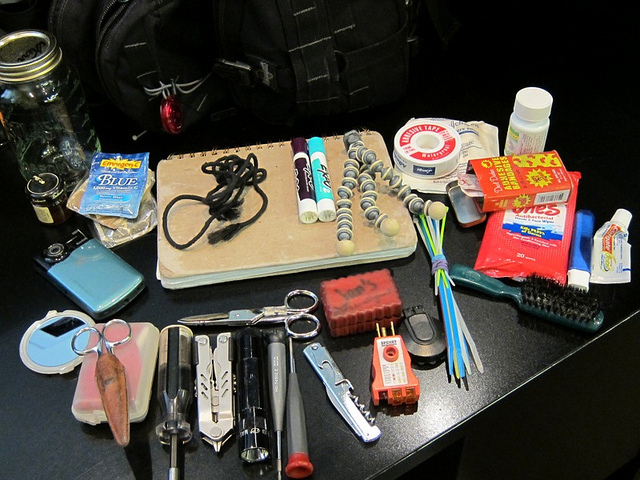Please transcribe the text in this image. BLUE ches 